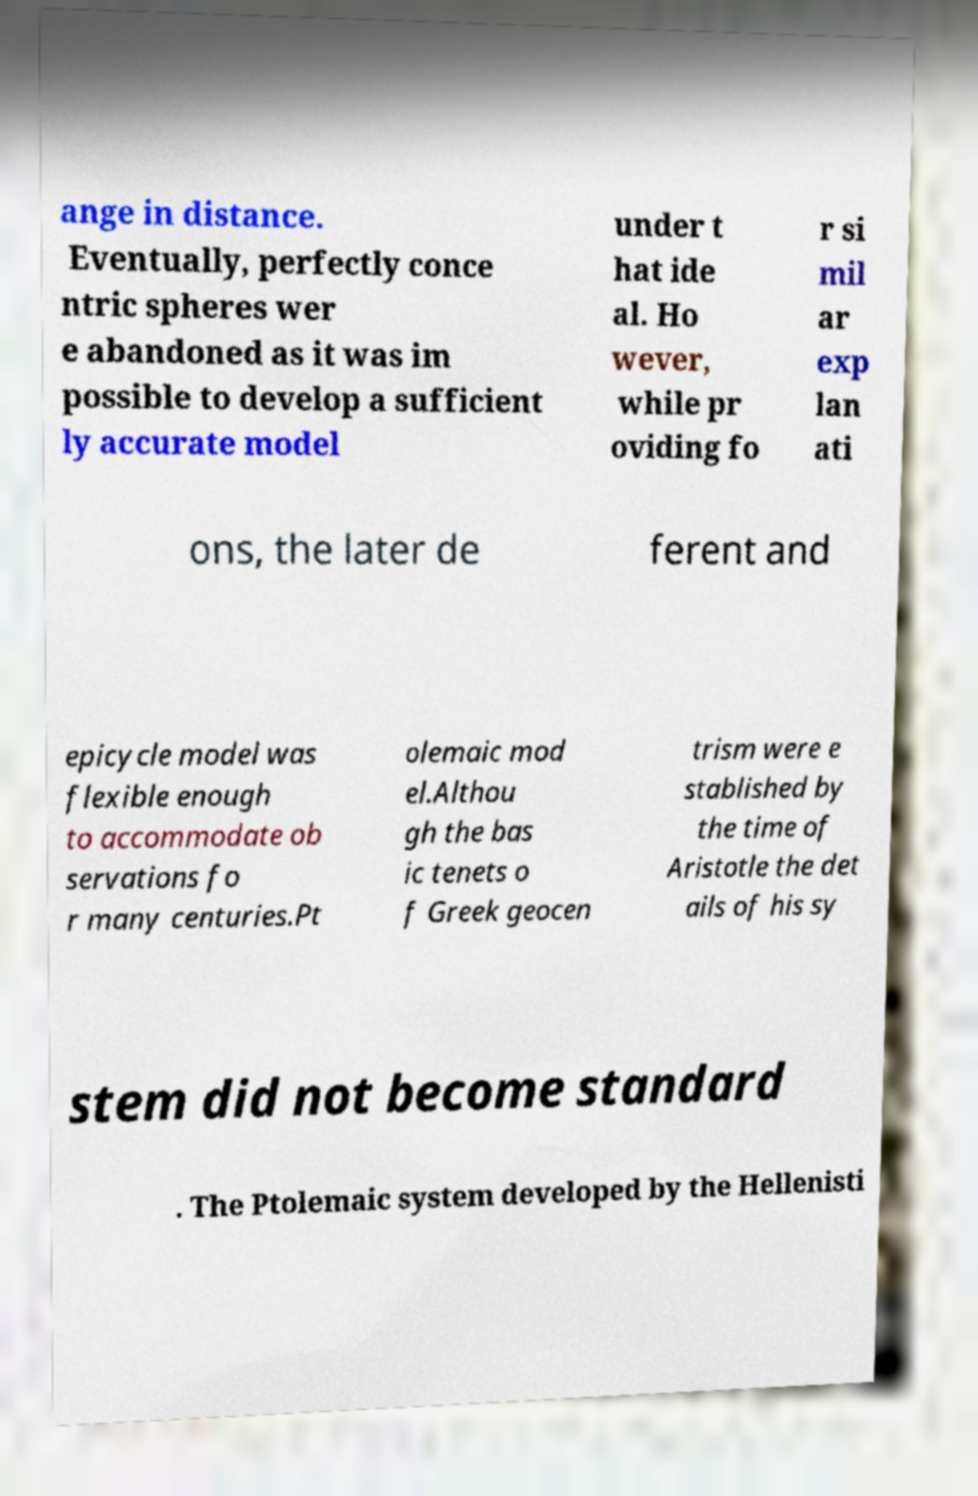Could you assist in decoding the text presented in this image and type it out clearly? ange in distance. Eventually, perfectly conce ntric spheres wer e abandoned as it was im possible to develop a sufficient ly accurate model under t hat ide al. Ho wever, while pr oviding fo r si mil ar exp lan ati ons, the later de ferent and epicycle model was flexible enough to accommodate ob servations fo r many centuries.Pt olemaic mod el.Althou gh the bas ic tenets o f Greek geocen trism were e stablished by the time of Aristotle the det ails of his sy stem did not become standard . The Ptolemaic system developed by the Hellenisti 